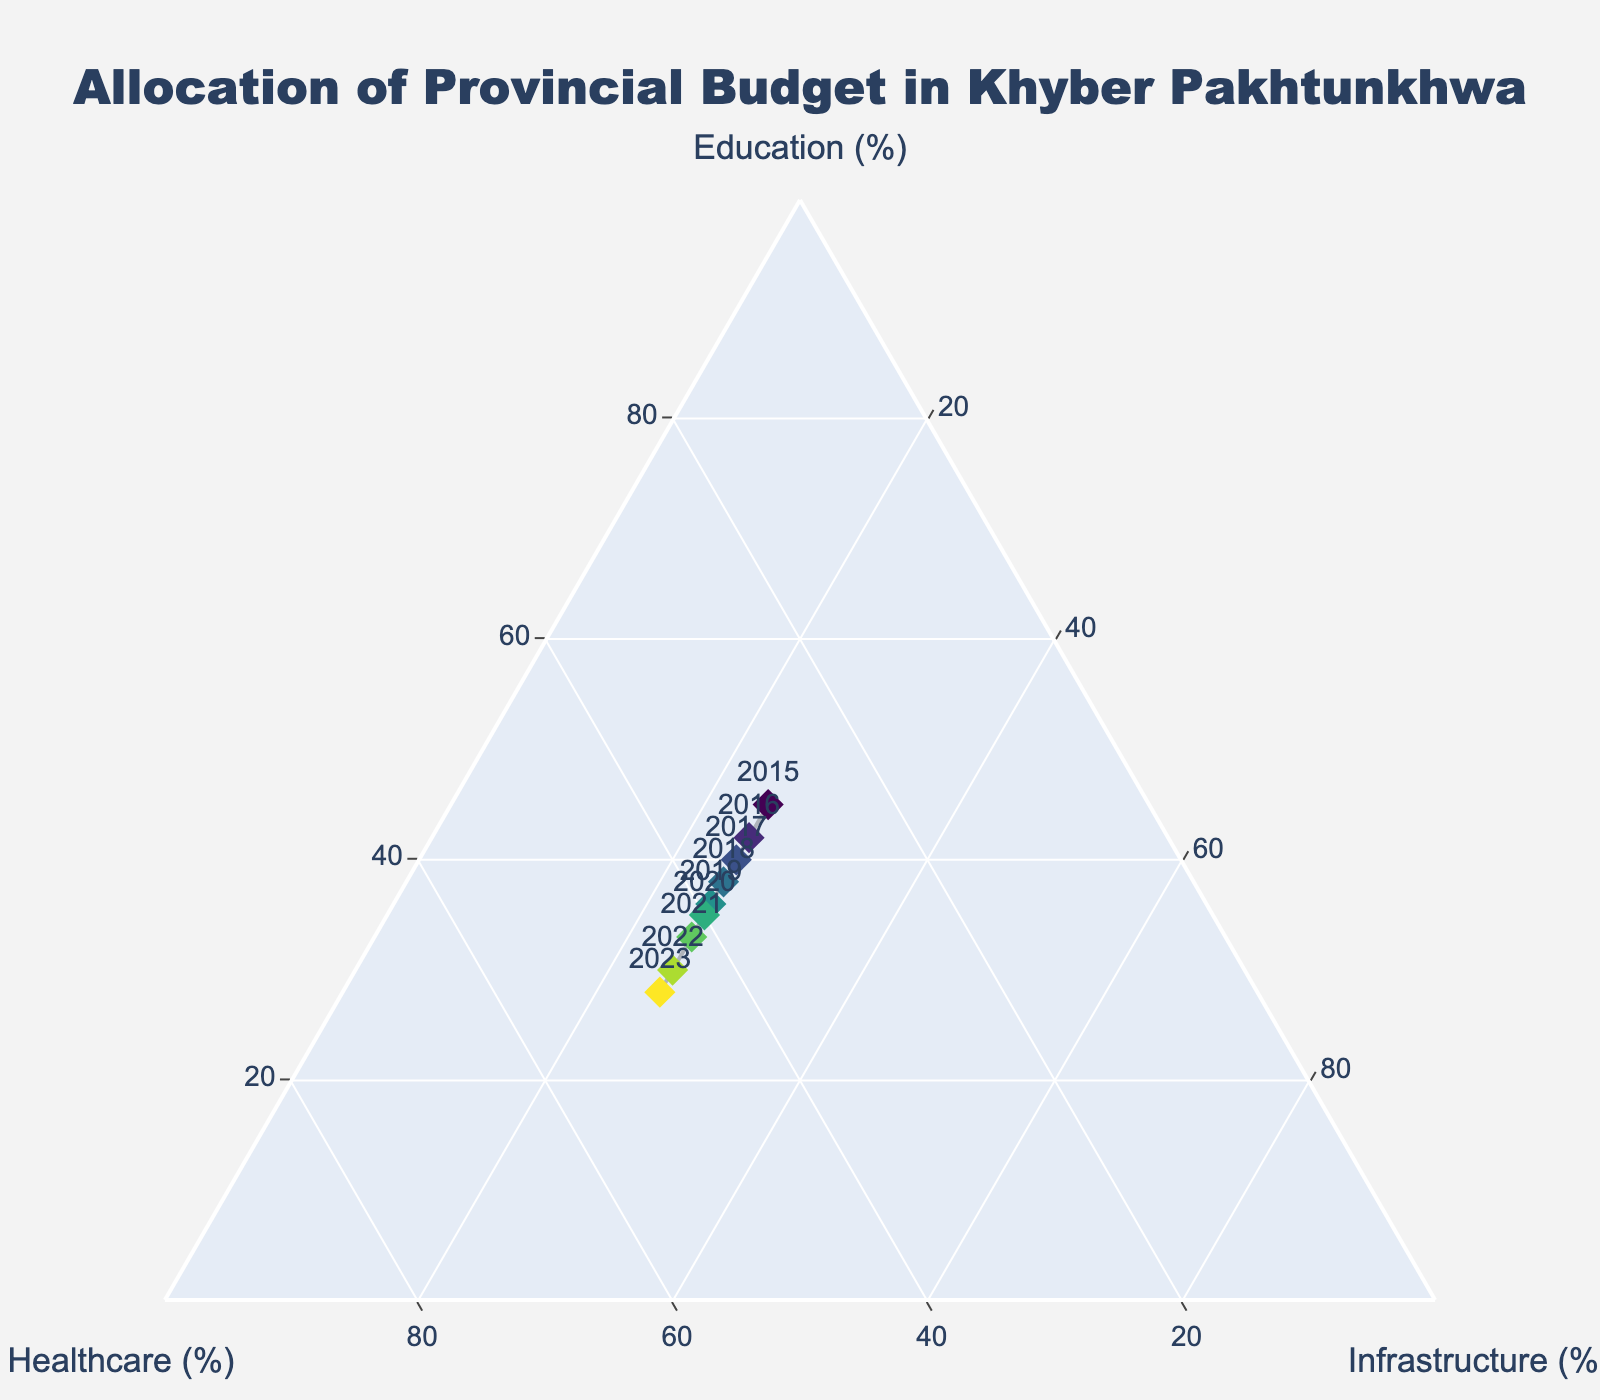Which sector received the highest budget allocation in 2023? In 2023, the highest percentage allocation was directed towards Healthcare as seen by the position of that year's data point being closest to the Healthcare axis in the Ternary Plot.
Answer: Healthcare What is the trend in budget allocation towards Education from 2015 to 2023? The data points show a decreasing trend in the percentage of the budget allocated to Education, dropping from 45% in 2015 to 28% in 2023.
Answer: Decreasing Which year had the equal allocation between Healthcare and Infrastructure? None of the years had equal allocation between Healthcare and Infrastructure as the plotted data points show distinct values for these sectors each year.
Answer: None How does the allocation for Healthcare change from 2015 to 2023? The budget allocation for Healthcare shows an increasing trend starting from 30% in 2015 to 47% in 2023. This can be observed by following the Healthcare axis on the Ternary Plot.
Answer: Increasing In which year was the gap between the budget allocation for Education and Healthcare the smallest? In 2020, the gap between the budget allocations for Education and Healthcare was minimal at 5% (Education: 35%, Healthcare: 40%). This is evident from the positions of the data points for that year on the plot.
Answer: 2020 What's the average allocation for Education over these years? The average can be found by summing the percentages of Education allocation from 2015 to 2023 (45+42+40+38+36+35+33+30+28) and dividing by the number of years, 9. That gives (327 / 9) = 36.33%.
Answer: 36.33% During which years did the Healthcare sector see the most significant annual increase in its budget allocation? Between 2021 and 2022, Healthcare saw the most significant annual increase in budget allocation from 42% to 45%. By comparing the positioning of points on Healthcare axis on the plot, it becomes evident.
Answer: 2021-2022 What was the total increase in healthcare allocation from 2015 to 2023? The increase can be calculated by subtracting the initial allocation in 2015 (30%) from the allocation in 2023 (47%), resulting in an increase of 17%.
Answer: 17% Which sector consistently received the smallest portion of the budget across all years? Infrastructure consistently received 25% of the budget allocation each year, which is the smallest portion compared to Education and Healthcare. This can be confirmed by the Ternary Plot positions.
Answer: Infrastructure 